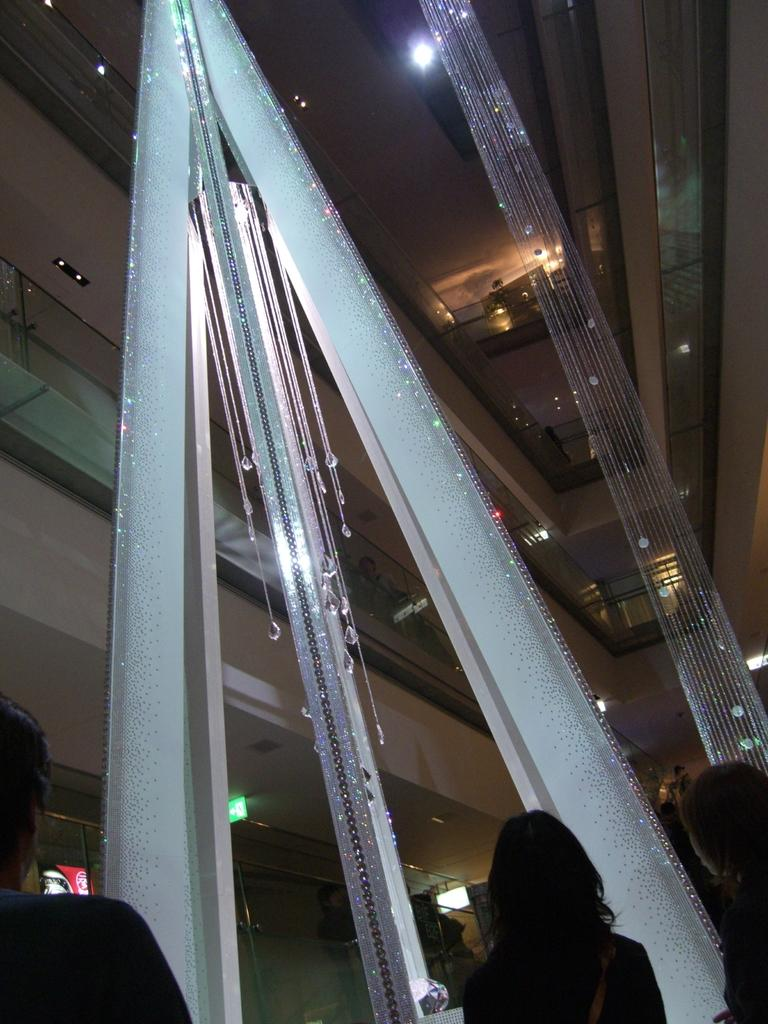How many people are in the image? There are three persons in the image. What type of setting is depicted in the image? The image appears to be an inside view of a building. What objects can be seen in the background of the image? There are glasses and lights in the background of the image. How many zebras are visible in the image? There are no zebras present in the image. What type of currency is being used by the persons in the image? The provided facts do not mention any currency or financial transactions, so it cannot be determined from the image. 